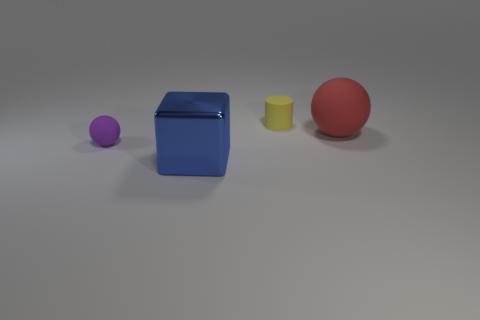Are there any other things that are the same material as the blue thing?
Keep it short and to the point. No. The tiny yellow thing that is made of the same material as the purple object is what shape?
Offer a terse response. Cylinder. What is the color of the sphere that is right of the ball that is on the left side of the cylinder?
Keep it short and to the point. Red. Does the tiny rubber sphere have the same color as the tiny cylinder?
Give a very brief answer. No. What material is the sphere behind the thing on the left side of the large blue shiny block made of?
Your answer should be compact. Rubber. What is the material of the small purple object that is the same shape as the red matte object?
Ensure brevity in your answer.  Rubber. Is there a ball that is to the right of the small object that is in front of the matte ball that is right of the tiny sphere?
Give a very brief answer. Yes. What number of other objects are there of the same color as the large metallic object?
Make the answer very short. 0. How many objects are right of the large metallic object and left of the big rubber object?
Keep it short and to the point. 1. The large red thing is what shape?
Provide a short and direct response. Sphere. 